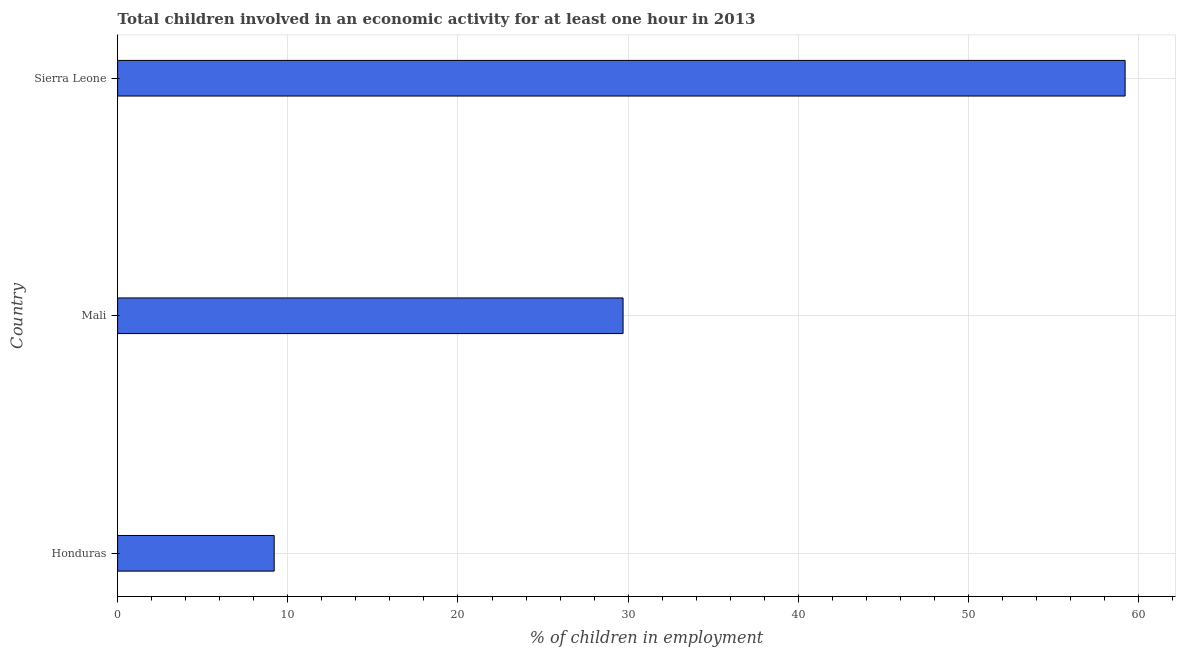Does the graph contain any zero values?
Offer a very short reply. No. Does the graph contain grids?
Offer a very short reply. Yes. What is the title of the graph?
Make the answer very short. Total children involved in an economic activity for at least one hour in 2013. What is the label or title of the X-axis?
Provide a succinct answer. % of children in employment. What is the percentage of children in employment in Mali?
Your response must be concise. 29.7. Across all countries, what is the maximum percentage of children in employment?
Give a very brief answer. 59.2. In which country was the percentage of children in employment maximum?
Provide a succinct answer. Sierra Leone. In which country was the percentage of children in employment minimum?
Make the answer very short. Honduras. What is the sum of the percentage of children in employment?
Keep it short and to the point. 98.1. What is the difference between the percentage of children in employment in Honduras and Mali?
Ensure brevity in your answer.  -20.5. What is the average percentage of children in employment per country?
Ensure brevity in your answer.  32.7. What is the median percentage of children in employment?
Give a very brief answer. 29.7. What is the ratio of the percentage of children in employment in Honduras to that in Sierra Leone?
Provide a short and direct response. 0.15. Is the percentage of children in employment in Mali less than that in Sierra Leone?
Offer a very short reply. Yes. What is the difference between the highest and the second highest percentage of children in employment?
Make the answer very short. 29.5. How many bars are there?
Keep it short and to the point. 3. Are all the bars in the graph horizontal?
Your answer should be compact. Yes. How many countries are there in the graph?
Make the answer very short. 3. What is the difference between two consecutive major ticks on the X-axis?
Make the answer very short. 10. What is the % of children in employment of Honduras?
Make the answer very short. 9.2. What is the % of children in employment of Mali?
Offer a terse response. 29.7. What is the % of children in employment in Sierra Leone?
Provide a succinct answer. 59.2. What is the difference between the % of children in employment in Honduras and Mali?
Keep it short and to the point. -20.5. What is the difference between the % of children in employment in Mali and Sierra Leone?
Your response must be concise. -29.5. What is the ratio of the % of children in employment in Honduras to that in Mali?
Offer a very short reply. 0.31. What is the ratio of the % of children in employment in Honduras to that in Sierra Leone?
Your answer should be compact. 0.15. What is the ratio of the % of children in employment in Mali to that in Sierra Leone?
Provide a succinct answer. 0.5. 